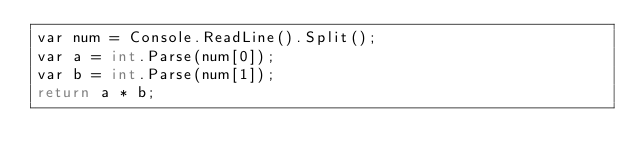Convert code to text. <code><loc_0><loc_0><loc_500><loc_500><_C#_>var num = Console.ReadLine().Split();
var a = int.Parse(num[0]);
var b = int.Parse(num[1]);
return a * b;
</code> 